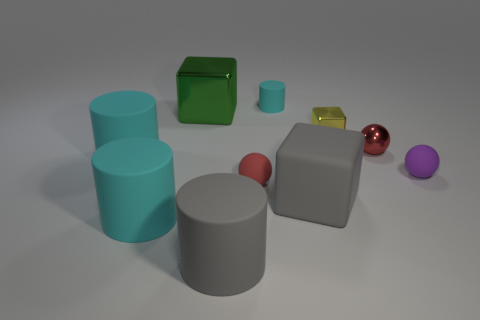There is a cylinder that is the same color as the matte cube; what is its size?
Provide a succinct answer. Large. Is there a tiny metal cube in front of the cyan matte cylinder that is behind the shiny block to the right of the big metal block?
Your answer should be compact. Yes. What is the shape of the small matte thing that is the same color as the metal sphere?
Provide a succinct answer. Sphere. What number of tiny things are either gray rubber cubes or balls?
Your answer should be compact. 3. There is a tiny rubber object right of the tiny yellow object; is its shape the same as the red metal thing?
Keep it short and to the point. Yes. Are there fewer metallic spheres than gray things?
Provide a short and direct response. Yes. Are there any other things that are the same color as the tiny metal cube?
Offer a terse response. No. What shape is the small rubber thing that is right of the yellow shiny cube?
Offer a terse response. Sphere. There is a tiny metallic sphere; does it have the same color as the small matte sphere left of the big matte block?
Keep it short and to the point. Yes. Is the number of small purple matte spheres that are on the right side of the small yellow cube the same as the number of red metallic objects that are left of the tiny red shiny sphere?
Your answer should be very brief. No. 